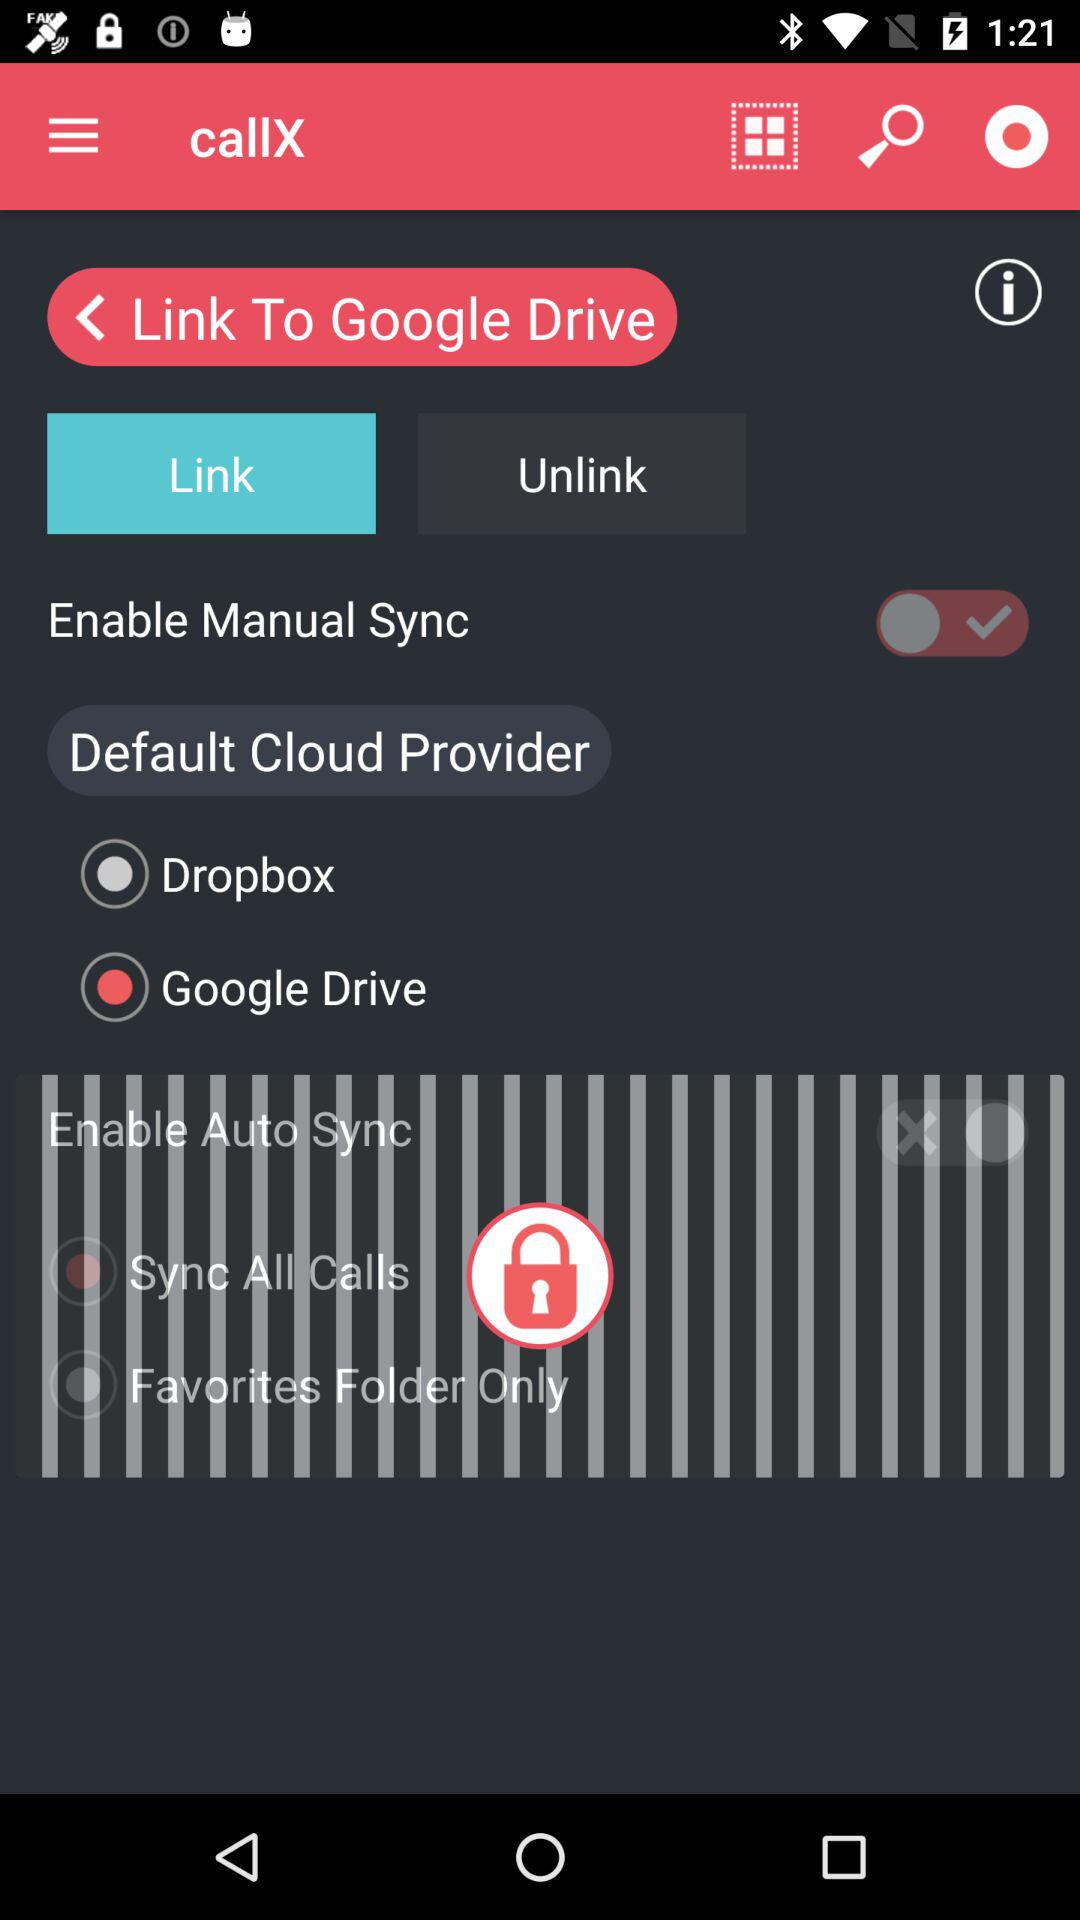What is the status of the "Manual Sync"? The status of the "Manual Sync" is "off". 